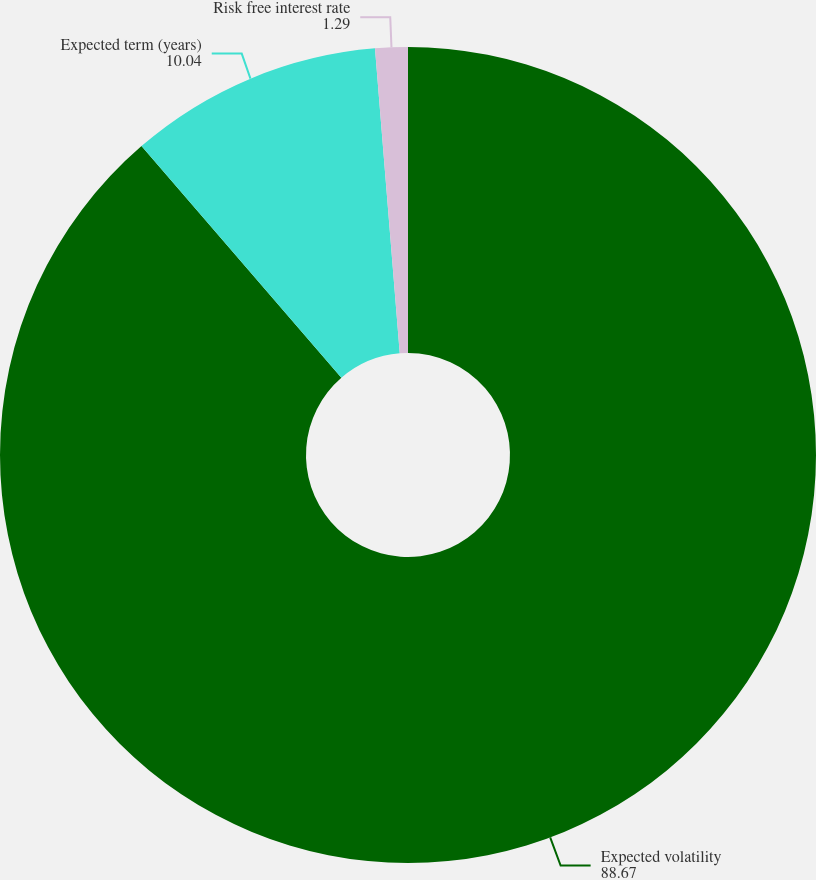Convert chart to OTSL. <chart><loc_0><loc_0><loc_500><loc_500><pie_chart><fcel>Expected volatility<fcel>Expected term (years)<fcel>Risk free interest rate<nl><fcel>88.67%<fcel>10.04%<fcel>1.29%<nl></chart> 